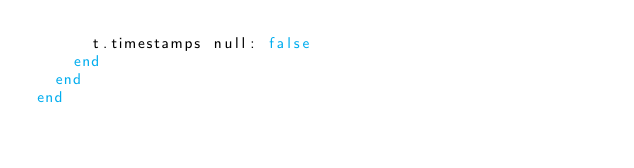Convert code to text. <code><loc_0><loc_0><loc_500><loc_500><_Ruby_>      t.timestamps null: false
    end
  end
end
</code> 